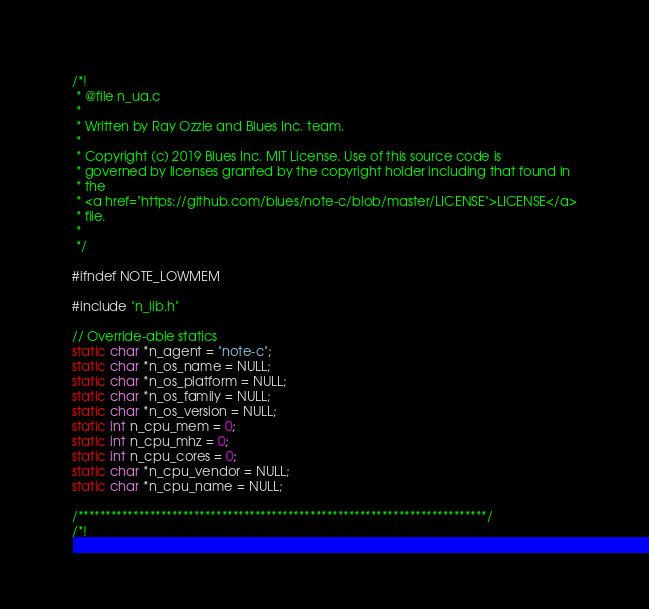Convert code to text. <code><loc_0><loc_0><loc_500><loc_500><_C_>/*!
 * @file n_ua.c
 *
 * Written by Ray Ozzie and Blues Inc. team.
 *
 * Copyright (c) 2019 Blues Inc. MIT License. Use of this source code is
 * governed by licenses granted by the copyright holder including that found in
 * the
 * <a href="https://github.com/blues/note-c/blob/master/LICENSE">LICENSE</a>
 * file.
 *
 */

#ifndef NOTE_LOWMEM

#include "n_lib.h"

// Override-able statics
static char *n_agent = "note-c";
static char *n_os_name = NULL;
static char *n_os_platform = NULL;
static char *n_os_family = NULL;
static char *n_os_version = NULL;
static int n_cpu_mem = 0;
static int n_cpu_mhz = 0;
static int n_cpu_cores = 0;
static char *n_cpu_vendor = NULL;
static char *n_cpu_name = NULL;

/**************************************************************************/
/*!</code> 